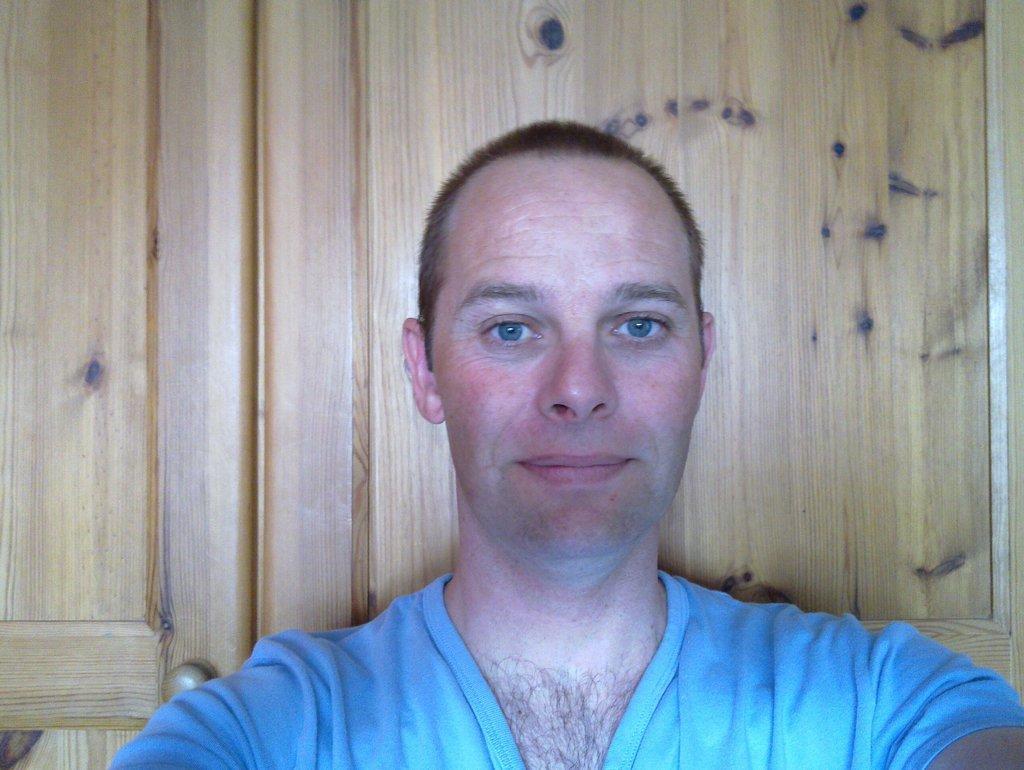Please provide a concise description of this image. In the image a person is standing. Behind him there is door. 